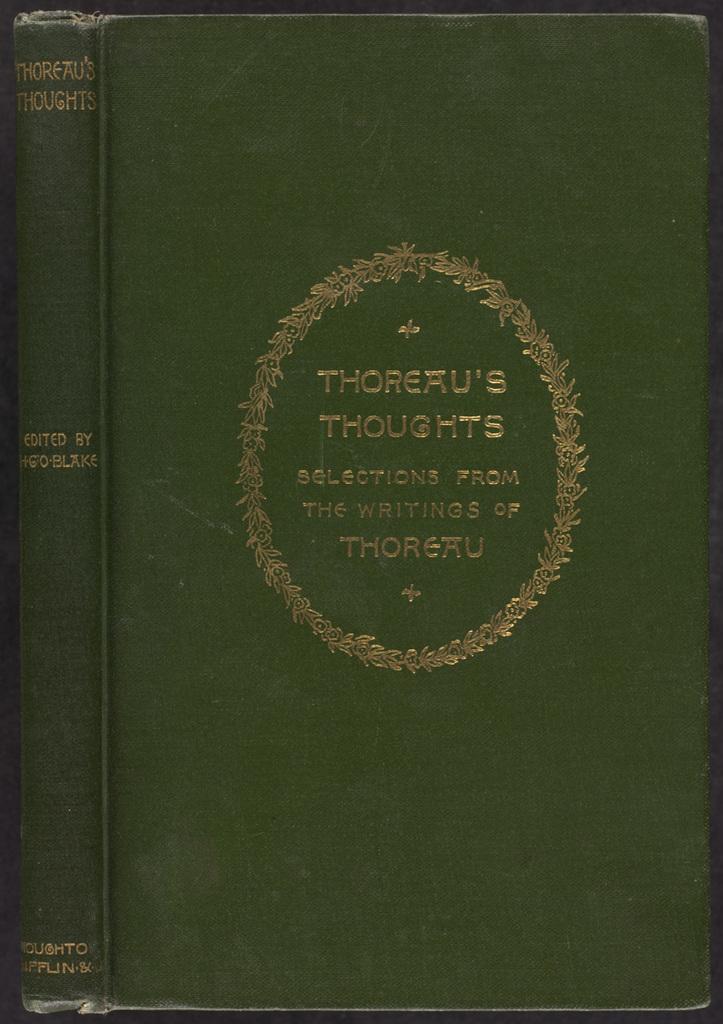Who wrote this book?
Give a very brief answer. Thoreau. 